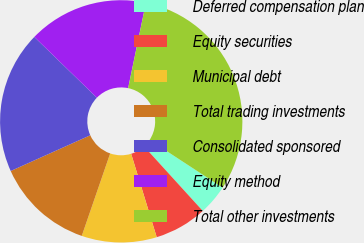Convert chart. <chart><loc_0><loc_0><loc_500><loc_500><pie_chart><fcel>Deferred compensation plan<fcel>Equity securities<fcel>Municipal debt<fcel>Total trading investments<fcel>Consolidated sponsored<fcel>Equity method<fcel>Total other investments<nl><fcel>4.03%<fcel>7.02%<fcel>10.01%<fcel>13.0%<fcel>18.99%<fcel>16.0%<fcel>30.95%<nl></chart> 